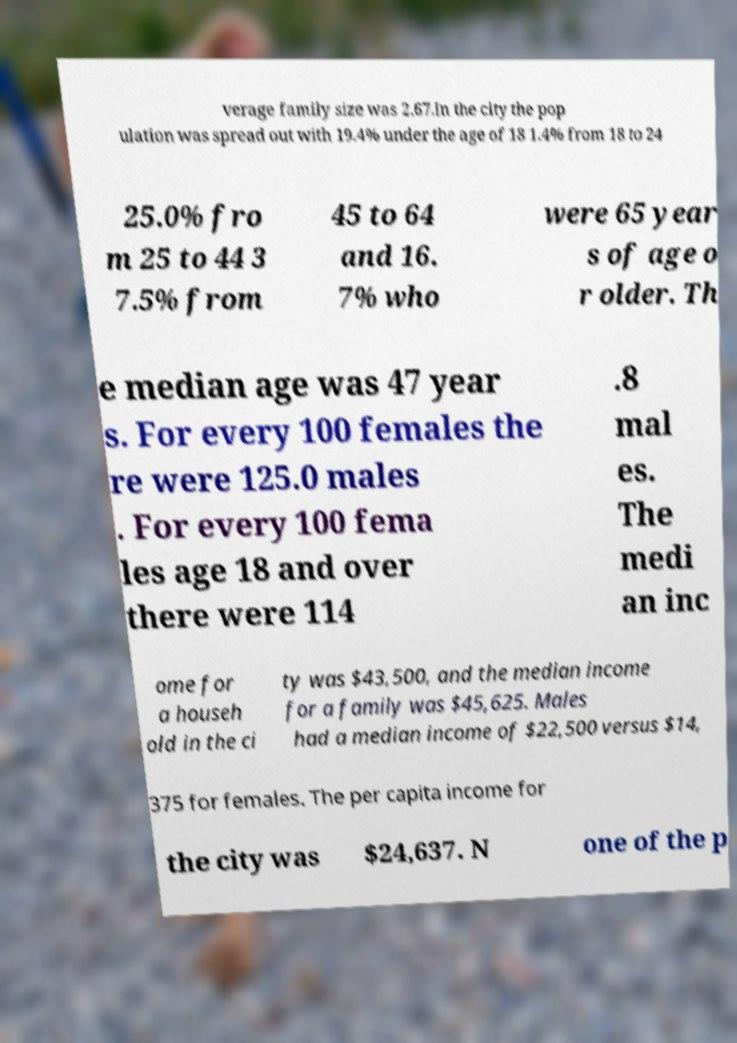There's text embedded in this image that I need extracted. Can you transcribe it verbatim? verage family size was 2.67.In the city the pop ulation was spread out with 19.4% under the age of 18 1.4% from 18 to 24 25.0% fro m 25 to 44 3 7.5% from 45 to 64 and 16. 7% who were 65 year s of age o r older. Th e median age was 47 year s. For every 100 females the re were 125.0 males . For every 100 fema les age 18 and over there were 114 .8 mal es. The medi an inc ome for a househ old in the ci ty was $43,500, and the median income for a family was $45,625. Males had a median income of $22,500 versus $14, 375 for females. The per capita income for the city was $24,637. N one of the p 